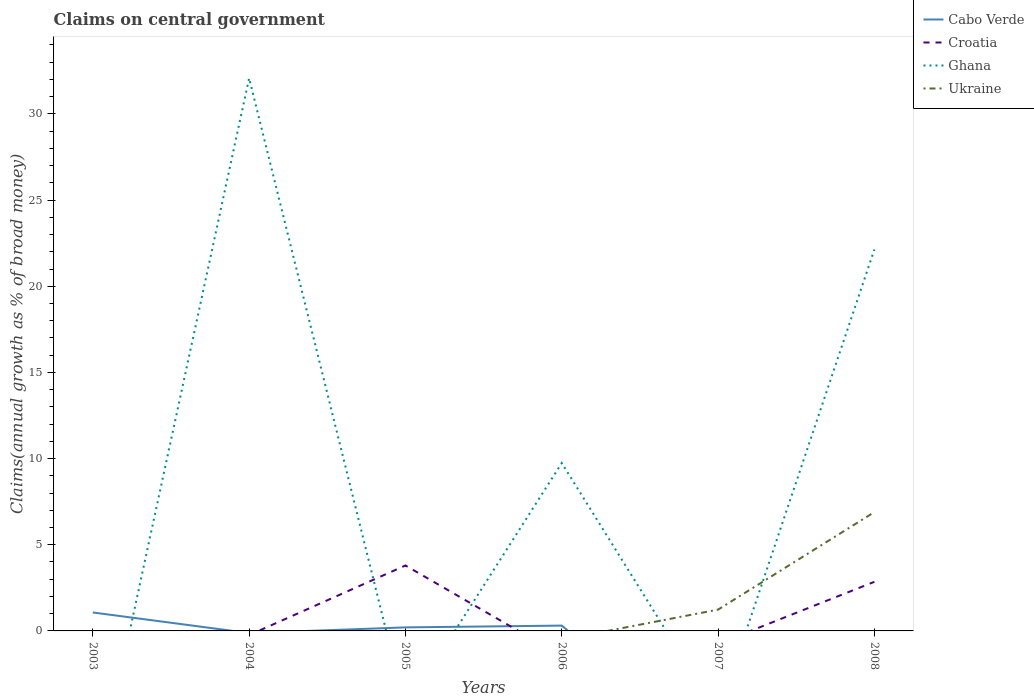How many different coloured lines are there?
Make the answer very short. 4. Is the number of lines equal to the number of legend labels?
Make the answer very short. No. What is the total percentage of broad money claimed on centeral government in Ghana in the graph?
Offer a terse response. 9.94. What is the difference between the highest and the second highest percentage of broad money claimed on centeral government in Ghana?
Keep it short and to the point. 32.08. How many lines are there?
Offer a terse response. 4. What is the difference between two consecutive major ticks on the Y-axis?
Your answer should be very brief. 5. Are the values on the major ticks of Y-axis written in scientific E-notation?
Keep it short and to the point. No. Does the graph contain any zero values?
Your response must be concise. Yes. Does the graph contain grids?
Provide a short and direct response. No. Where does the legend appear in the graph?
Your response must be concise. Top right. How are the legend labels stacked?
Provide a succinct answer. Vertical. What is the title of the graph?
Give a very brief answer. Claims on central government. What is the label or title of the X-axis?
Offer a terse response. Years. What is the label or title of the Y-axis?
Your response must be concise. Claims(annual growth as % of broad money). What is the Claims(annual growth as % of broad money) in Cabo Verde in 2003?
Give a very brief answer. 1.07. What is the Claims(annual growth as % of broad money) in Croatia in 2003?
Provide a succinct answer. 0. What is the Claims(annual growth as % of broad money) of Cabo Verde in 2004?
Your response must be concise. 0. What is the Claims(annual growth as % of broad money) of Ghana in 2004?
Your response must be concise. 32.08. What is the Claims(annual growth as % of broad money) in Cabo Verde in 2005?
Your answer should be compact. 0.21. What is the Claims(annual growth as % of broad money) of Croatia in 2005?
Offer a very short reply. 3.8. What is the Claims(annual growth as % of broad money) of Ukraine in 2005?
Keep it short and to the point. 0. What is the Claims(annual growth as % of broad money) in Cabo Verde in 2006?
Your answer should be compact. 0.31. What is the Claims(annual growth as % of broad money) in Ghana in 2006?
Provide a succinct answer. 9.74. What is the Claims(annual growth as % of broad money) in Ukraine in 2006?
Provide a succinct answer. 0. What is the Claims(annual growth as % of broad money) in Croatia in 2007?
Provide a succinct answer. 0. What is the Claims(annual growth as % of broad money) of Ghana in 2007?
Provide a short and direct response. 0. What is the Claims(annual growth as % of broad money) in Ukraine in 2007?
Keep it short and to the point. 1.24. What is the Claims(annual growth as % of broad money) in Cabo Verde in 2008?
Provide a succinct answer. 0. What is the Claims(annual growth as % of broad money) in Croatia in 2008?
Your answer should be very brief. 2.85. What is the Claims(annual growth as % of broad money) of Ghana in 2008?
Give a very brief answer. 22.13. What is the Claims(annual growth as % of broad money) in Ukraine in 2008?
Provide a succinct answer. 6.9. Across all years, what is the maximum Claims(annual growth as % of broad money) of Cabo Verde?
Keep it short and to the point. 1.07. Across all years, what is the maximum Claims(annual growth as % of broad money) of Croatia?
Keep it short and to the point. 3.8. Across all years, what is the maximum Claims(annual growth as % of broad money) of Ghana?
Ensure brevity in your answer.  32.08. Across all years, what is the maximum Claims(annual growth as % of broad money) of Ukraine?
Ensure brevity in your answer.  6.9. Across all years, what is the minimum Claims(annual growth as % of broad money) of Cabo Verde?
Make the answer very short. 0. What is the total Claims(annual growth as % of broad money) in Cabo Verde in the graph?
Make the answer very short. 1.59. What is the total Claims(annual growth as % of broad money) of Croatia in the graph?
Give a very brief answer. 6.65. What is the total Claims(annual growth as % of broad money) of Ghana in the graph?
Keep it short and to the point. 63.95. What is the total Claims(annual growth as % of broad money) in Ukraine in the graph?
Keep it short and to the point. 8.13. What is the difference between the Claims(annual growth as % of broad money) of Cabo Verde in 2003 and that in 2005?
Give a very brief answer. 0.87. What is the difference between the Claims(annual growth as % of broad money) in Cabo Verde in 2003 and that in 2006?
Give a very brief answer. 0.76. What is the difference between the Claims(annual growth as % of broad money) in Ghana in 2004 and that in 2006?
Offer a terse response. 22.34. What is the difference between the Claims(annual growth as % of broad money) in Ghana in 2004 and that in 2008?
Make the answer very short. 9.94. What is the difference between the Claims(annual growth as % of broad money) of Cabo Verde in 2005 and that in 2006?
Offer a terse response. -0.1. What is the difference between the Claims(annual growth as % of broad money) of Croatia in 2005 and that in 2008?
Give a very brief answer. 0.95. What is the difference between the Claims(annual growth as % of broad money) in Ghana in 2006 and that in 2008?
Your answer should be compact. -12.39. What is the difference between the Claims(annual growth as % of broad money) of Ukraine in 2007 and that in 2008?
Your response must be concise. -5.66. What is the difference between the Claims(annual growth as % of broad money) in Cabo Verde in 2003 and the Claims(annual growth as % of broad money) in Ghana in 2004?
Your answer should be very brief. -31.01. What is the difference between the Claims(annual growth as % of broad money) of Cabo Verde in 2003 and the Claims(annual growth as % of broad money) of Croatia in 2005?
Provide a short and direct response. -2.73. What is the difference between the Claims(annual growth as % of broad money) of Cabo Verde in 2003 and the Claims(annual growth as % of broad money) of Ghana in 2006?
Ensure brevity in your answer.  -8.67. What is the difference between the Claims(annual growth as % of broad money) of Cabo Verde in 2003 and the Claims(annual growth as % of broad money) of Ukraine in 2007?
Offer a terse response. -0.16. What is the difference between the Claims(annual growth as % of broad money) of Cabo Verde in 2003 and the Claims(annual growth as % of broad money) of Croatia in 2008?
Keep it short and to the point. -1.78. What is the difference between the Claims(annual growth as % of broad money) of Cabo Verde in 2003 and the Claims(annual growth as % of broad money) of Ghana in 2008?
Your answer should be very brief. -21.06. What is the difference between the Claims(annual growth as % of broad money) of Cabo Verde in 2003 and the Claims(annual growth as % of broad money) of Ukraine in 2008?
Provide a short and direct response. -5.82. What is the difference between the Claims(annual growth as % of broad money) in Ghana in 2004 and the Claims(annual growth as % of broad money) in Ukraine in 2007?
Your answer should be compact. 30.84. What is the difference between the Claims(annual growth as % of broad money) in Ghana in 2004 and the Claims(annual growth as % of broad money) in Ukraine in 2008?
Your answer should be compact. 25.18. What is the difference between the Claims(annual growth as % of broad money) of Cabo Verde in 2005 and the Claims(annual growth as % of broad money) of Ghana in 2006?
Offer a very short reply. -9.54. What is the difference between the Claims(annual growth as % of broad money) in Croatia in 2005 and the Claims(annual growth as % of broad money) in Ghana in 2006?
Your answer should be very brief. -5.94. What is the difference between the Claims(annual growth as % of broad money) in Cabo Verde in 2005 and the Claims(annual growth as % of broad money) in Ukraine in 2007?
Give a very brief answer. -1.03. What is the difference between the Claims(annual growth as % of broad money) in Croatia in 2005 and the Claims(annual growth as % of broad money) in Ukraine in 2007?
Your answer should be compact. 2.56. What is the difference between the Claims(annual growth as % of broad money) in Cabo Verde in 2005 and the Claims(annual growth as % of broad money) in Croatia in 2008?
Provide a short and direct response. -2.65. What is the difference between the Claims(annual growth as % of broad money) in Cabo Verde in 2005 and the Claims(annual growth as % of broad money) in Ghana in 2008?
Offer a very short reply. -21.93. What is the difference between the Claims(annual growth as % of broad money) of Cabo Verde in 2005 and the Claims(annual growth as % of broad money) of Ukraine in 2008?
Offer a very short reply. -6.69. What is the difference between the Claims(annual growth as % of broad money) in Croatia in 2005 and the Claims(annual growth as % of broad money) in Ghana in 2008?
Ensure brevity in your answer.  -18.34. What is the difference between the Claims(annual growth as % of broad money) in Croatia in 2005 and the Claims(annual growth as % of broad money) in Ukraine in 2008?
Your answer should be very brief. -3.1. What is the difference between the Claims(annual growth as % of broad money) in Cabo Verde in 2006 and the Claims(annual growth as % of broad money) in Ukraine in 2007?
Offer a very short reply. -0.93. What is the difference between the Claims(annual growth as % of broad money) of Ghana in 2006 and the Claims(annual growth as % of broad money) of Ukraine in 2007?
Keep it short and to the point. 8.5. What is the difference between the Claims(annual growth as % of broad money) of Cabo Verde in 2006 and the Claims(annual growth as % of broad money) of Croatia in 2008?
Keep it short and to the point. -2.54. What is the difference between the Claims(annual growth as % of broad money) in Cabo Verde in 2006 and the Claims(annual growth as % of broad money) in Ghana in 2008?
Offer a very short reply. -21.83. What is the difference between the Claims(annual growth as % of broad money) in Cabo Verde in 2006 and the Claims(annual growth as % of broad money) in Ukraine in 2008?
Offer a terse response. -6.59. What is the difference between the Claims(annual growth as % of broad money) in Ghana in 2006 and the Claims(annual growth as % of broad money) in Ukraine in 2008?
Offer a very short reply. 2.85. What is the average Claims(annual growth as % of broad money) in Cabo Verde per year?
Make the answer very short. 0.26. What is the average Claims(annual growth as % of broad money) in Croatia per year?
Ensure brevity in your answer.  1.11. What is the average Claims(annual growth as % of broad money) in Ghana per year?
Provide a short and direct response. 10.66. What is the average Claims(annual growth as % of broad money) in Ukraine per year?
Ensure brevity in your answer.  1.36. In the year 2005, what is the difference between the Claims(annual growth as % of broad money) in Cabo Verde and Claims(annual growth as % of broad money) in Croatia?
Keep it short and to the point. -3.59. In the year 2006, what is the difference between the Claims(annual growth as % of broad money) in Cabo Verde and Claims(annual growth as % of broad money) in Ghana?
Keep it short and to the point. -9.43. In the year 2008, what is the difference between the Claims(annual growth as % of broad money) of Croatia and Claims(annual growth as % of broad money) of Ghana?
Ensure brevity in your answer.  -19.28. In the year 2008, what is the difference between the Claims(annual growth as % of broad money) of Croatia and Claims(annual growth as % of broad money) of Ukraine?
Offer a very short reply. -4.04. In the year 2008, what is the difference between the Claims(annual growth as % of broad money) of Ghana and Claims(annual growth as % of broad money) of Ukraine?
Your response must be concise. 15.24. What is the ratio of the Claims(annual growth as % of broad money) of Cabo Verde in 2003 to that in 2005?
Offer a very short reply. 5.22. What is the ratio of the Claims(annual growth as % of broad money) in Cabo Verde in 2003 to that in 2006?
Your answer should be very brief. 3.46. What is the ratio of the Claims(annual growth as % of broad money) of Ghana in 2004 to that in 2006?
Give a very brief answer. 3.29. What is the ratio of the Claims(annual growth as % of broad money) in Ghana in 2004 to that in 2008?
Ensure brevity in your answer.  1.45. What is the ratio of the Claims(annual growth as % of broad money) of Cabo Verde in 2005 to that in 2006?
Provide a short and direct response. 0.66. What is the ratio of the Claims(annual growth as % of broad money) in Croatia in 2005 to that in 2008?
Provide a short and direct response. 1.33. What is the ratio of the Claims(annual growth as % of broad money) in Ghana in 2006 to that in 2008?
Provide a short and direct response. 0.44. What is the ratio of the Claims(annual growth as % of broad money) in Ukraine in 2007 to that in 2008?
Offer a very short reply. 0.18. What is the difference between the highest and the second highest Claims(annual growth as % of broad money) in Cabo Verde?
Provide a short and direct response. 0.76. What is the difference between the highest and the second highest Claims(annual growth as % of broad money) in Ghana?
Your answer should be compact. 9.94. What is the difference between the highest and the lowest Claims(annual growth as % of broad money) of Cabo Verde?
Offer a very short reply. 1.07. What is the difference between the highest and the lowest Claims(annual growth as % of broad money) in Croatia?
Your response must be concise. 3.8. What is the difference between the highest and the lowest Claims(annual growth as % of broad money) of Ghana?
Keep it short and to the point. 32.08. What is the difference between the highest and the lowest Claims(annual growth as % of broad money) of Ukraine?
Your answer should be very brief. 6.9. 